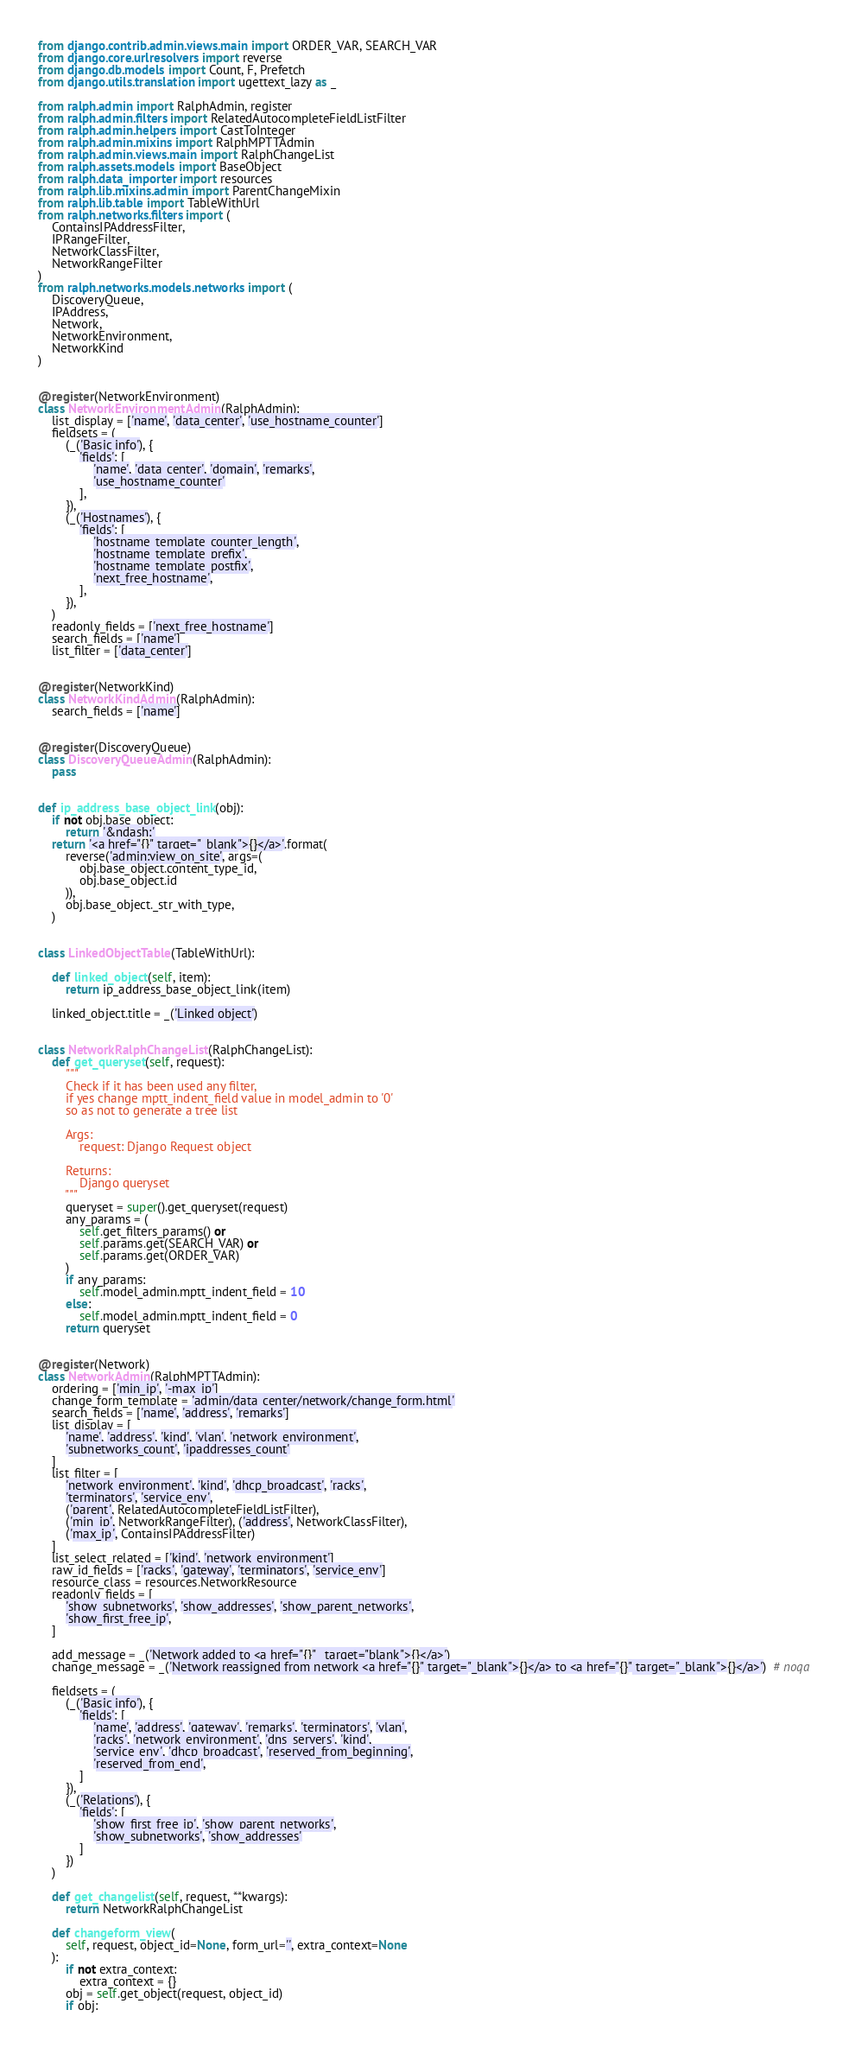Convert code to text. <code><loc_0><loc_0><loc_500><loc_500><_Python_>from django.contrib.admin.views.main import ORDER_VAR, SEARCH_VAR
from django.core.urlresolvers import reverse
from django.db.models import Count, F, Prefetch
from django.utils.translation import ugettext_lazy as _

from ralph.admin import RalphAdmin, register
from ralph.admin.filters import RelatedAutocompleteFieldListFilter
from ralph.admin.helpers import CastToInteger
from ralph.admin.mixins import RalphMPTTAdmin
from ralph.admin.views.main import RalphChangeList
from ralph.assets.models import BaseObject
from ralph.data_importer import resources
from ralph.lib.mixins.admin import ParentChangeMixin
from ralph.lib.table import TableWithUrl
from ralph.networks.filters import (
    ContainsIPAddressFilter,
    IPRangeFilter,
    NetworkClassFilter,
    NetworkRangeFilter
)
from ralph.networks.models.networks import (
    DiscoveryQueue,
    IPAddress,
    Network,
    NetworkEnvironment,
    NetworkKind
)


@register(NetworkEnvironment)
class NetworkEnvironmentAdmin(RalphAdmin):
    list_display = ['name', 'data_center', 'use_hostname_counter']
    fieldsets = (
        (_('Basic info'), {
            'fields': [
                'name', 'data_center', 'domain', 'remarks',
                'use_hostname_counter'
            ],
        }),
        (_('Hostnames'), {
            'fields': [
                'hostname_template_counter_length',
                'hostname_template_prefix',
                'hostname_template_postfix',
                'next_free_hostname',
            ],
        }),
    )
    readonly_fields = ['next_free_hostname']
    search_fields = ['name']
    list_filter = ['data_center']


@register(NetworkKind)
class NetworkKindAdmin(RalphAdmin):
    search_fields = ['name']


@register(DiscoveryQueue)
class DiscoveryQueueAdmin(RalphAdmin):
    pass


def ip_address_base_object_link(obj):
    if not obj.base_object:
        return '&ndash;'
    return '<a href="{}" target="_blank">{}</a>'.format(
        reverse('admin:view_on_site', args=(
            obj.base_object.content_type_id,
            obj.base_object.id
        )),
        obj.base_object._str_with_type,
    )


class LinkedObjectTable(TableWithUrl):

    def linked_object(self, item):
        return ip_address_base_object_link(item)

    linked_object.title = _('Linked object')


class NetworkRalphChangeList(RalphChangeList):
    def get_queryset(self, request):
        """
        Check if it has been used any filter,
        if yes change mptt_indent_field value in model_admin to '0'
        so as not to generate a tree list

        Args:
            request: Django Request object

        Returns:
            Django queryset
        """
        queryset = super().get_queryset(request)
        any_params = (
            self.get_filters_params() or
            self.params.get(SEARCH_VAR) or
            self.params.get(ORDER_VAR)
        )
        if any_params:
            self.model_admin.mptt_indent_field = 10
        else:
            self.model_admin.mptt_indent_field = 0
        return queryset


@register(Network)
class NetworkAdmin(RalphMPTTAdmin):
    ordering = ['min_ip', '-max_ip']
    change_form_template = 'admin/data_center/network/change_form.html'
    search_fields = ['name', 'address', 'remarks']
    list_display = [
        'name', 'address', 'kind', 'vlan', 'network_environment',
        'subnetworks_count', 'ipaddresses_count'
    ]
    list_filter = [
        'network_environment', 'kind', 'dhcp_broadcast', 'racks',
        'terminators', 'service_env',
        ('parent', RelatedAutocompleteFieldListFilter),
        ('min_ip', NetworkRangeFilter), ('address', NetworkClassFilter),
        ('max_ip', ContainsIPAddressFilter)
    ]
    list_select_related = ['kind', 'network_environment']
    raw_id_fields = ['racks', 'gateway', 'terminators', 'service_env']
    resource_class = resources.NetworkResource
    readonly_fields = [
        'show_subnetworks', 'show_addresses', 'show_parent_networks',
        'show_first_free_ip',
    ]

    add_message = _('Network added to <a href="{}" _target="blank">{}</a>')
    change_message = _('Network reassigned from network <a href="{}" target="_blank">{}</a> to <a href="{}" target="_blank">{}</a>')  # noqa

    fieldsets = (
        (_('Basic info'), {
            'fields': [
                'name', 'address', 'gateway', 'remarks', 'terminators', 'vlan',
                'racks', 'network_environment', 'dns_servers', 'kind',
                'service_env', 'dhcp_broadcast', 'reserved_from_beginning',
                'reserved_from_end',
            ]
        }),
        (_('Relations'), {
            'fields': [
                'show_first_free_ip', 'show_parent_networks',
                'show_subnetworks', 'show_addresses'
            ]
        })
    )

    def get_changelist(self, request, **kwargs):
        return NetworkRalphChangeList

    def changeform_view(
        self, request, object_id=None, form_url='', extra_context=None
    ):
        if not extra_context:
            extra_context = {}
        obj = self.get_object(request, object_id)
        if obj:</code> 